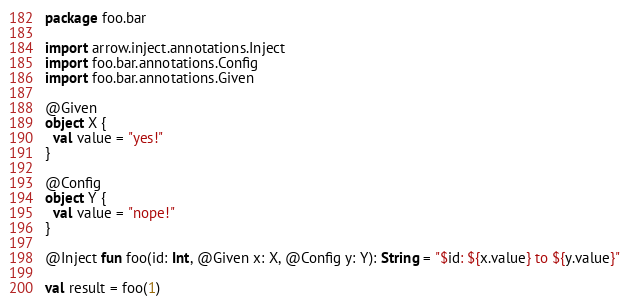Convert code to text. <code><loc_0><loc_0><loc_500><loc_500><_Kotlin_>package foo.bar

import arrow.inject.annotations.Inject
import foo.bar.annotations.Config
import foo.bar.annotations.Given

@Given
object X {
  val value = "yes!"
}

@Config
object Y {
  val value = "nope!"
}

@Inject fun foo(id: Int, @Given x: X, @Config y: Y): String = "$id: ${x.value} to ${y.value}"

val result = foo(1)
</code> 